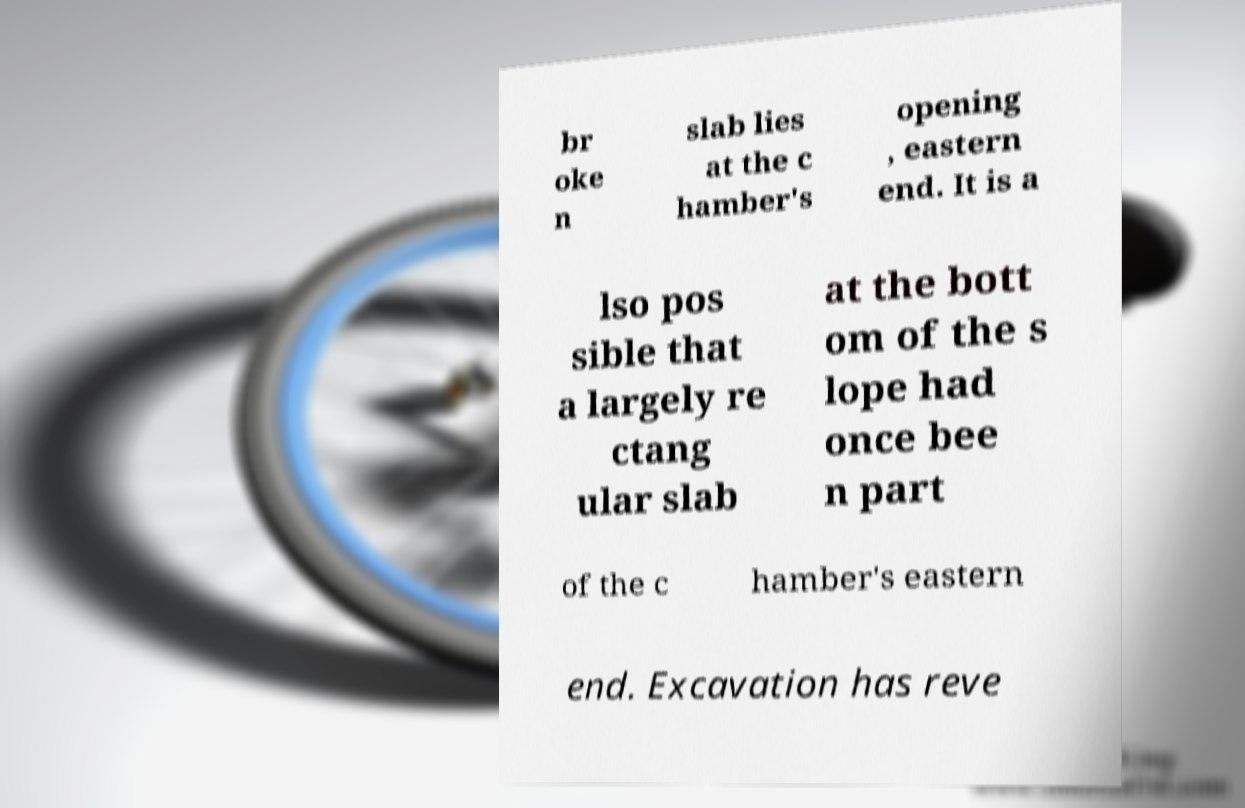Could you assist in decoding the text presented in this image and type it out clearly? br oke n slab lies at the c hamber's opening , eastern end. It is a lso pos sible that a largely re ctang ular slab at the bott om of the s lope had once bee n part of the c hamber's eastern end. Excavation has reve 